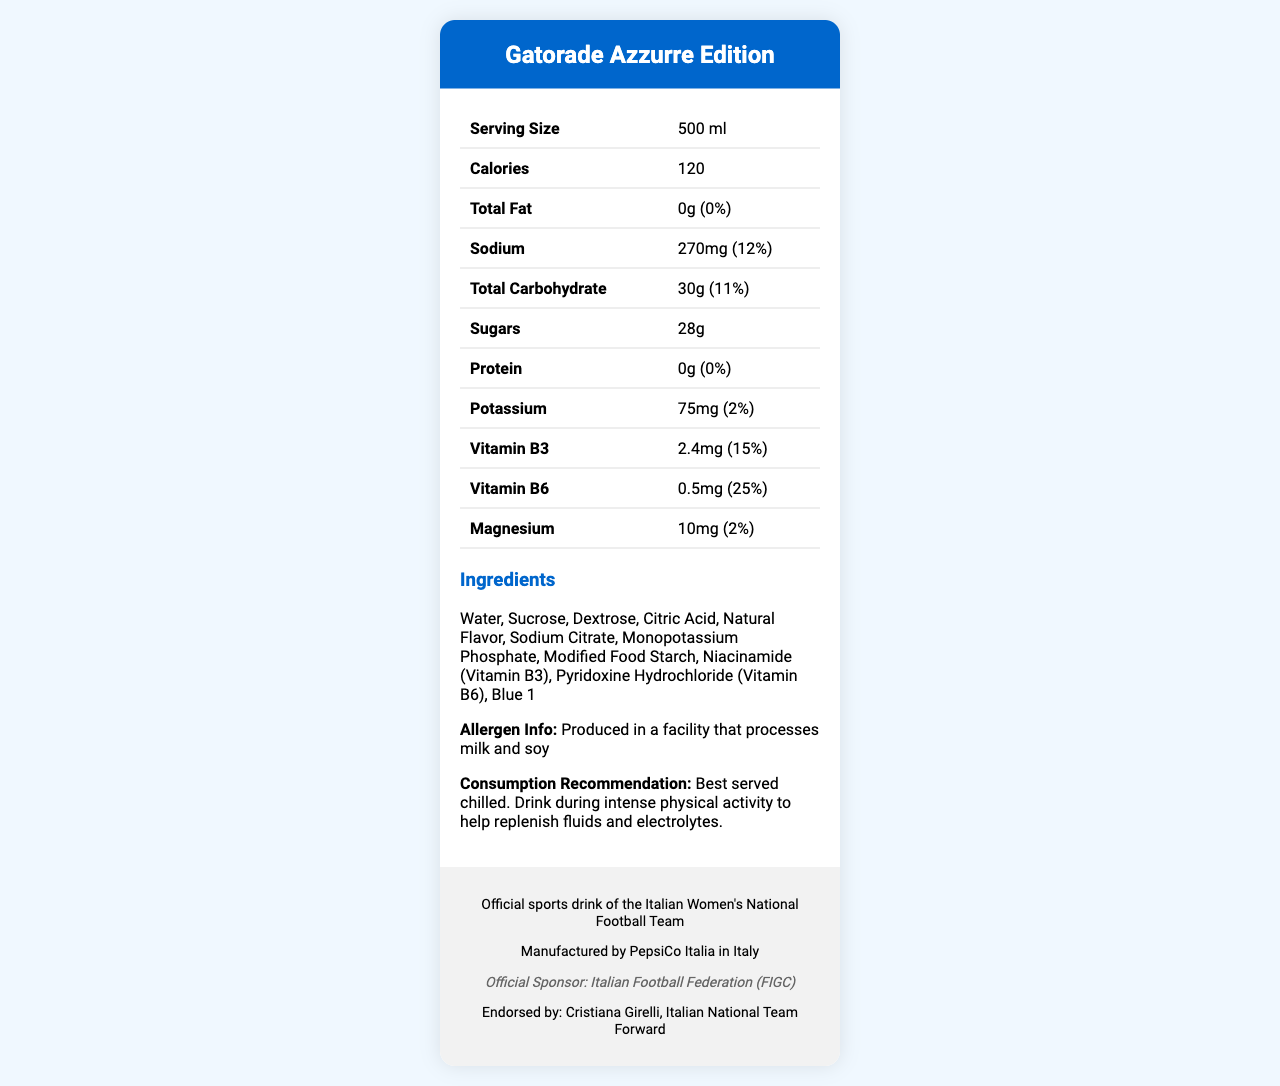what is the serving size? The serving size is mentioned in the table under the "Serving Size" row.
Answer: 500 ml how many calories are in one serving of the drink? The number of calories is listed in the table under the "Calories" row.
Answer: 120 what is the amount of total carbohydrates in the drink? The total carbohydrates are listed in the table under the "Total Carbohydrate" row.
Answer: 30g does the drink contain any protein? The protein amount is listed as "0g" in the table under the "Protein" row.
Answer: No who endorses the "Gatorade Azzurre Edition"? The player's endorsement is mentioned in the footer section of the document.
Answer: Cristiana Girelli what is the sodium content per serving? A. 270mg B. 75mg C. 500mg D. 150mg The sodium content of 270mg is listed in the table under the "Sodium" row.
Answer: A. 270mg which vitamin is present in the highest amount by daily value percentage? I. Vitamin B3 II. Vitamin B6 III. Magnesium IV. Potassium Vitamin B6 has a daily value of 25%, which is higher than the daily values of the other vitamins and minerals listed.
Answer: II. Vitamin B6 is the drink suitable for someone with a soy allergy? The document mentions that the drink is produced in a facility that processes soy, which may not be suitable for someone with a soy allergy.
Answer: No what is the main purpose of the "Gatorade Azzurre Edition"? The consumption recommendation states that it is best served chilled and to drink during intense physical activity to help replenish fluids and electrolytes.
Answer: Replenish fluids and electrolytes during intense physical activity who manufactures the "Gatorade Azzurre Edition"? The manufacturer is mentioned in the footer section of the document.
Answer: PepsiCo Italia what are the main electrolytes present in the drink? The main electrolytes listed in the table are sodium (270mg), potassium (75mg), and magnesium (10mg).
Answer: Sodium, Potassium, Magnesium is the product recyclable? The document specifies that the product is recyclable.
Answer: Yes can you determine the caffeine content in the drink? The document does not provide any information about the caffeine content.
Answer: Cannot be determined summarize the main information in the document. The summary provides an overview of the product, including its purpose, nutritional content, manufacturer, endorsement, and special features.
Answer: The "Gatorade Azzurre Edition" is an official sports drink of the Italian Women's National Football Team, designed to replenish fluids and electrolytes during intense physical activity. It is manufactured by PepsiCo Italia and endorsed by Cristiana Girelli. The drink contains 120 calories per serving, with electrolytes like sodium, potassium, and magnesium. It contains vitamins B3 and B6 and is produced in a facility that processes milk and soy. The drink is best served chilled and is recyclable. 